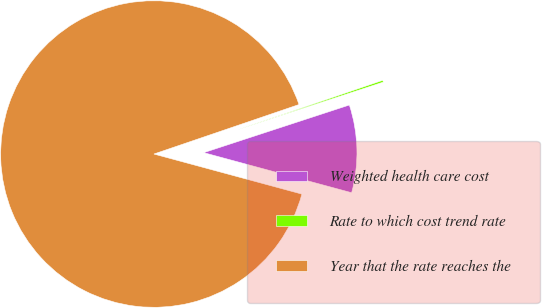<chart> <loc_0><loc_0><loc_500><loc_500><pie_chart><fcel>Weighted health care cost<fcel>Rate to which cost trend rate<fcel>Year that the rate reaches the<nl><fcel>9.24%<fcel>0.2%<fcel>90.56%<nl></chart> 